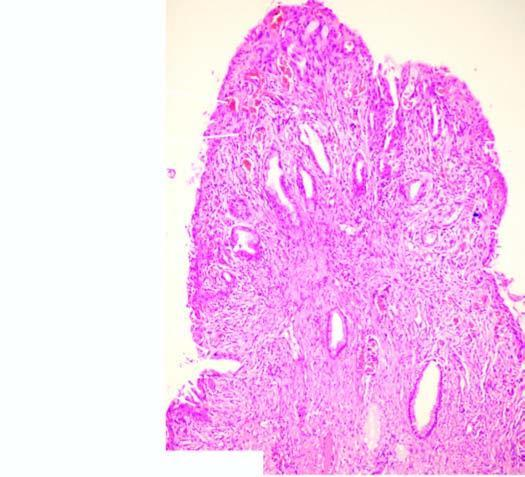what is covered by endocervical mucosa with squamous metaplasia?
Answer the question using a single word or phrase. Surface 